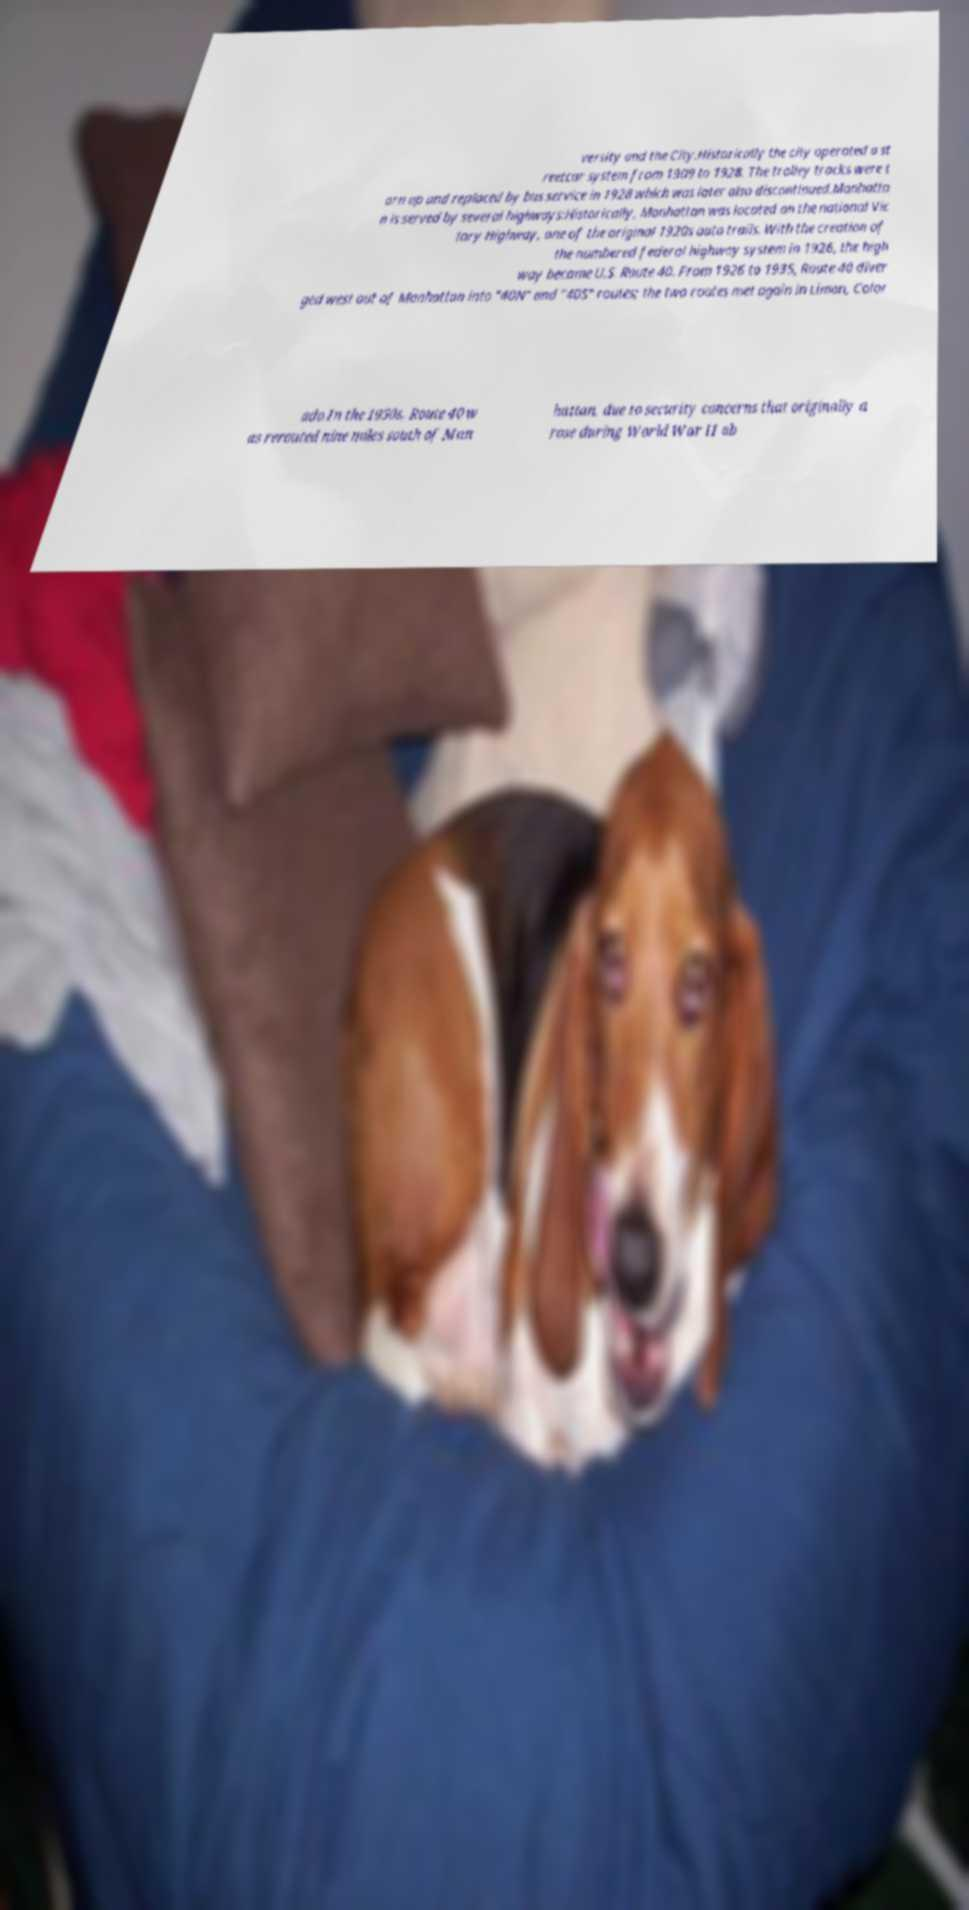There's text embedded in this image that I need extracted. Can you transcribe it verbatim? versity and the City.Historically the city operated a st reetcar system from 1909 to 1928. The trolley tracks were t orn up and replaced by bus service in 1928 which was later also discontinued.Manhatta n is served by several highways:Historically, Manhattan was located on the national Vic tory Highway, one of the original 1920s auto trails. With the creation of the numbered federal highway system in 1926, the high way became U.S. Route 40. From 1926 to 1935, Route 40 diver ged west out of Manhattan into "40N" and "40S" routes; the two routes met again in Limon, Color ado.In the 1950s, Route 40 w as rerouted nine miles south of Man hattan, due to security concerns that originally a rose during World War II ab 